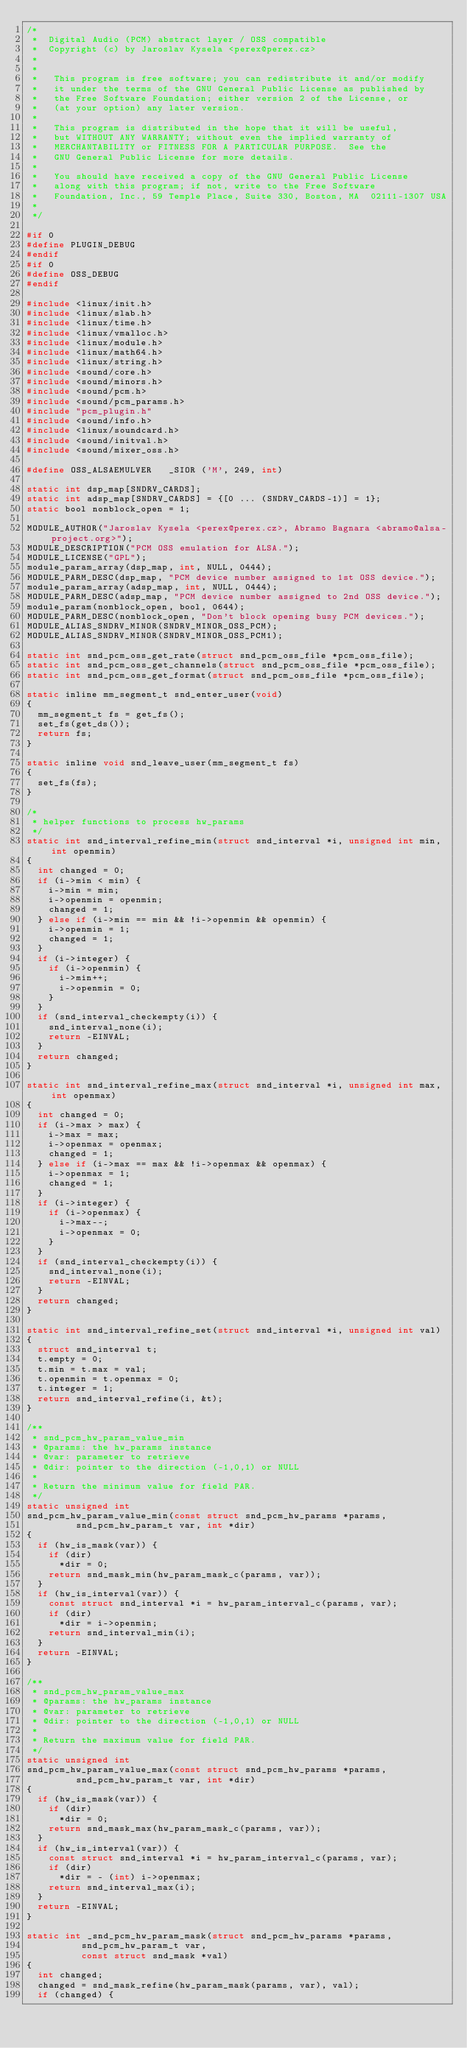Convert code to text. <code><loc_0><loc_0><loc_500><loc_500><_C_>/*
 *  Digital Audio (PCM) abstract layer / OSS compatible
 *  Copyright (c) by Jaroslav Kysela <perex@perex.cz>
 *
 *
 *   This program is free software; you can redistribute it and/or modify
 *   it under the terms of the GNU General Public License as published by
 *   the Free Software Foundation; either version 2 of the License, or
 *   (at your option) any later version.
 *
 *   This program is distributed in the hope that it will be useful,
 *   but WITHOUT ANY WARRANTY; without even the implied warranty of
 *   MERCHANTABILITY or FITNESS FOR A PARTICULAR PURPOSE.  See the
 *   GNU General Public License for more details.
 *
 *   You should have received a copy of the GNU General Public License
 *   along with this program; if not, write to the Free Software
 *   Foundation, Inc., 59 Temple Place, Suite 330, Boston, MA  02111-1307 USA
 *
 */

#if 0
#define PLUGIN_DEBUG
#endif
#if 0
#define OSS_DEBUG
#endif

#include <linux/init.h>
#include <linux/slab.h>
#include <linux/time.h>
#include <linux/vmalloc.h>
#include <linux/module.h>
#include <linux/math64.h>
#include <linux/string.h>
#include <sound/core.h>
#include <sound/minors.h>
#include <sound/pcm.h>
#include <sound/pcm_params.h>
#include "pcm_plugin.h"
#include <sound/info.h>
#include <linux/soundcard.h>
#include <sound/initval.h>
#include <sound/mixer_oss.h>

#define OSS_ALSAEMULVER		_SIOR ('M', 249, int)

static int dsp_map[SNDRV_CARDS];
static int adsp_map[SNDRV_CARDS] = {[0 ... (SNDRV_CARDS-1)] = 1};
static bool nonblock_open = 1;

MODULE_AUTHOR("Jaroslav Kysela <perex@perex.cz>, Abramo Bagnara <abramo@alsa-project.org>");
MODULE_DESCRIPTION("PCM OSS emulation for ALSA.");
MODULE_LICENSE("GPL");
module_param_array(dsp_map, int, NULL, 0444);
MODULE_PARM_DESC(dsp_map, "PCM device number assigned to 1st OSS device.");
module_param_array(adsp_map, int, NULL, 0444);
MODULE_PARM_DESC(adsp_map, "PCM device number assigned to 2nd OSS device.");
module_param(nonblock_open, bool, 0644);
MODULE_PARM_DESC(nonblock_open, "Don't block opening busy PCM devices.");
MODULE_ALIAS_SNDRV_MINOR(SNDRV_MINOR_OSS_PCM);
MODULE_ALIAS_SNDRV_MINOR(SNDRV_MINOR_OSS_PCM1);

static int snd_pcm_oss_get_rate(struct snd_pcm_oss_file *pcm_oss_file);
static int snd_pcm_oss_get_channels(struct snd_pcm_oss_file *pcm_oss_file);
static int snd_pcm_oss_get_format(struct snd_pcm_oss_file *pcm_oss_file);

static inline mm_segment_t snd_enter_user(void)
{
	mm_segment_t fs = get_fs();
	set_fs(get_ds());
	return fs;
}

static inline void snd_leave_user(mm_segment_t fs)
{
	set_fs(fs);
}

/*
 * helper functions to process hw_params
 */
static int snd_interval_refine_min(struct snd_interval *i, unsigned int min, int openmin)
{
	int changed = 0;
	if (i->min < min) {
		i->min = min;
		i->openmin = openmin;
		changed = 1;
	} else if (i->min == min && !i->openmin && openmin) {
		i->openmin = 1;
		changed = 1;
	}
	if (i->integer) {
		if (i->openmin) {
			i->min++;
			i->openmin = 0;
		}
	}
	if (snd_interval_checkempty(i)) {
		snd_interval_none(i);
		return -EINVAL;
	}
	return changed;
}

static int snd_interval_refine_max(struct snd_interval *i, unsigned int max, int openmax)
{
	int changed = 0;
	if (i->max > max) {
		i->max = max;
		i->openmax = openmax;
		changed = 1;
	} else if (i->max == max && !i->openmax && openmax) {
		i->openmax = 1;
		changed = 1;
	}
	if (i->integer) {
		if (i->openmax) {
			i->max--;
			i->openmax = 0;
		}
	}
	if (snd_interval_checkempty(i)) {
		snd_interval_none(i);
		return -EINVAL;
	}
	return changed;
}

static int snd_interval_refine_set(struct snd_interval *i, unsigned int val)
{
	struct snd_interval t;
	t.empty = 0;
	t.min = t.max = val;
	t.openmin = t.openmax = 0;
	t.integer = 1;
	return snd_interval_refine(i, &t);
}

/**
 * snd_pcm_hw_param_value_min
 * @params: the hw_params instance
 * @var: parameter to retrieve
 * @dir: pointer to the direction (-1,0,1) or NULL
 *
 * Return the minimum value for field PAR.
 */
static unsigned int
snd_pcm_hw_param_value_min(const struct snd_pcm_hw_params *params,
			   snd_pcm_hw_param_t var, int *dir)
{
	if (hw_is_mask(var)) {
		if (dir)
			*dir = 0;
		return snd_mask_min(hw_param_mask_c(params, var));
	}
	if (hw_is_interval(var)) {
		const struct snd_interval *i = hw_param_interval_c(params, var);
		if (dir)
			*dir = i->openmin;
		return snd_interval_min(i);
	}
	return -EINVAL;
}

/**
 * snd_pcm_hw_param_value_max
 * @params: the hw_params instance
 * @var: parameter to retrieve
 * @dir: pointer to the direction (-1,0,1) or NULL
 *
 * Return the maximum value for field PAR.
 */
static unsigned int
snd_pcm_hw_param_value_max(const struct snd_pcm_hw_params *params,
			   snd_pcm_hw_param_t var, int *dir)
{
	if (hw_is_mask(var)) {
		if (dir)
			*dir = 0;
		return snd_mask_max(hw_param_mask_c(params, var));
	}
	if (hw_is_interval(var)) {
		const struct snd_interval *i = hw_param_interval_c(params, var);
		if (dir)
			*dir = - (int) i->openmax;
		return snd_interval_max(i);
	}
	return -EINVAL;
}

static int _snd_pcm_hw_param_mask(struct snd_pcm_hw_params *params,
				  snd_pcm_hw_param_t var,
				  const struct snd_mask *val)
{
	int changed;
	changed = snd_mask_refine(hw_param_mask(params, var), val);
	if (changed) {</code> 